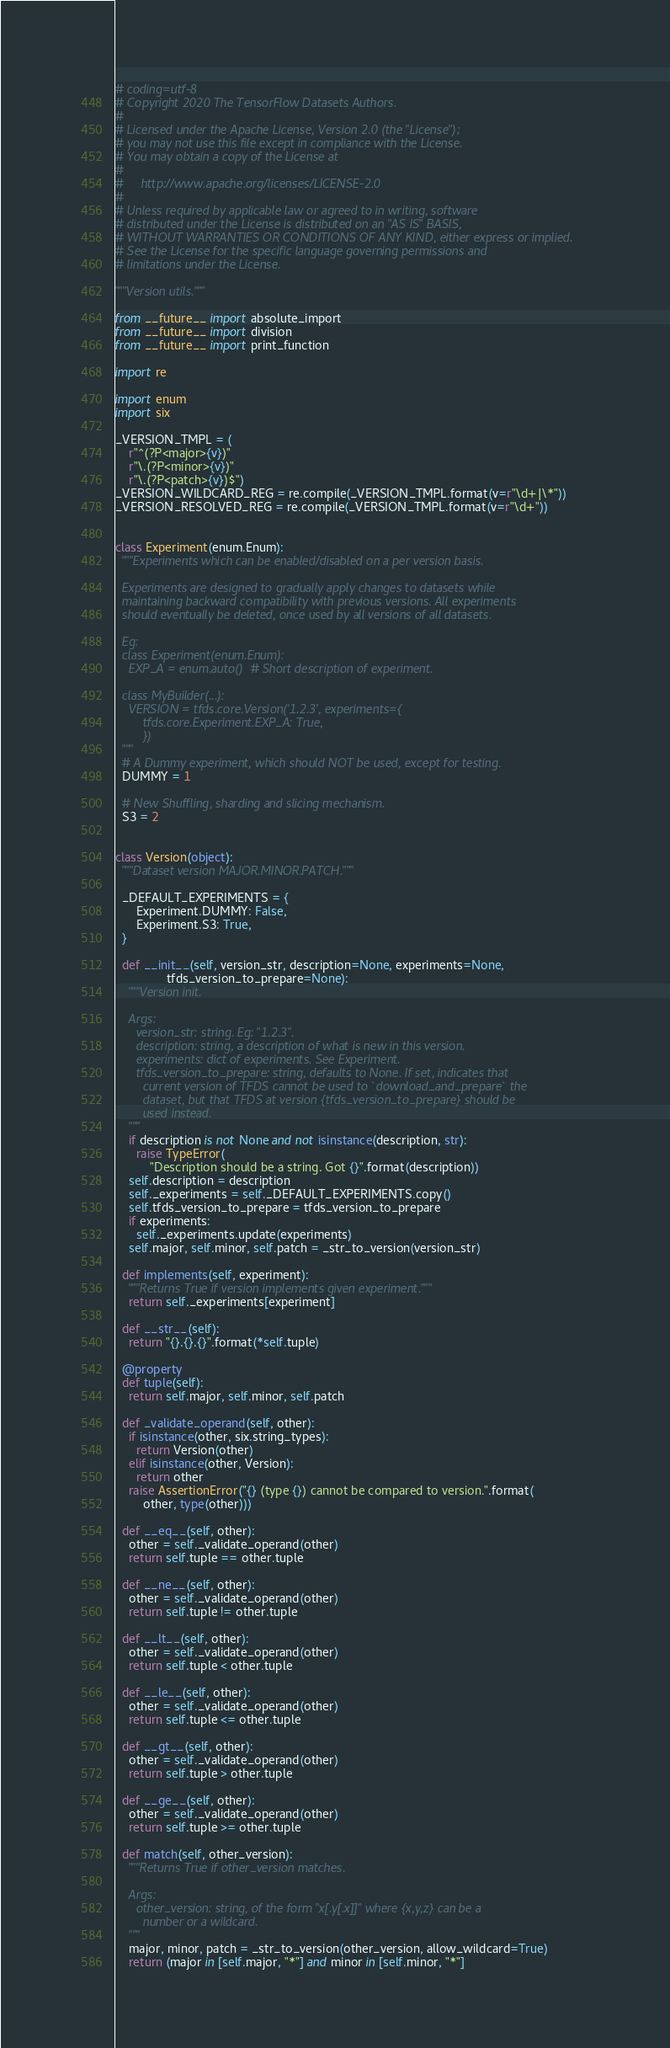Convert code to text. <code><loc_0><loc_0><loc_500><loc_500><_Python_># coding=utf-8
# Copyright 2020 The TensorFlow Datasets Authors.
#
# Licensed under the Apache License, Version 2.0 (the "License");
# you may not use this file except in compliance with the License.
# You may obtain a copy of the License at
#
#     http://www.apache.org/licenses/LICENSE-2.0
#
# Unless required by applicable law or agreed to in writing, software
# distributed under the License is distributed on an "AS IS" BASIS,
# WITHOUT WARRANTIES OR CONDITIONS OF ANY KIND, either express or implied.
# See the License for the specific language governing permissions and
# limitations under the License.

"""Version utils."""

from __future__ import absolute_import
from __future__ import division
from __future__ import print_function

import re

import enum
import six

_VERSION_TMPL = (
    r"^(?P<major>{v})"
    r"\.(?P<minor>{v})"
    r"\.(?P<patch>{v})$")
_VERSION_WILDCARD_REG = re.compile(_VERSION_TMPL.format(v=r"\d+|\*"))
_VERSION_RESOLVED_REG = re.compile(_VERSION_TMPL.format(v=r"\d+"))


class Experiment(enum.Enum):
  """Experiments which can be enabled/disabled on a per version basis.

  Experiments are designed to gradually apply changes to datasets while
  maintaining backward compatibility with previous versions. All experiments
  should eventually be deleted, once used by all versions of all datasets.

  Eg:
  class Experiment(enum.Enum):
    EXP_A = enum.auto()  # Short description of experiment.

  class MyBuilder(...):
    VERSION = tfds.core.Version('1.2.3', experiments={
        tfds.core.Experiment.EXP_A: True,
        })
  """
  # A Dummy experiment, which should NOT be used, except for testing.
  DUMMY = 1

  # New Shuffling, sharding and slicing mechanism.
  S3 = 2


class Version(object):
  """Dataset version MAJOR.MINOR.PATCH."""

  _DEFAULT_EXPERIMENTS = {
      Experiment.DUMMY: False,
      Experiment.S3: True,
  }

  def __init__(self, version_str, description=None, experiments=None,
               tfds_version_to_prepare=None):
    """Version init.

    Args:
      version_str: string. Eg: "1.2.3".
      description: string, a description of what is new in this version.
      experiments: dict of experiments. See Experiment.
      tfds_version_to_prepare: string, defaults to None. If set, indicates that
        current version of TFDS cannot be used to `download_and_prepare` the
        dataset, but that TFDS at version {tfds_version_to_prepare} should be
        used instead.
    """
    if description is not None and not isinstance(description, str):
      raise TypeError(
          "Description should be a string. Got {}".format(description))
    self.description = description
    self._experiments = self._DEFAULT_EXPERIMENTS.copy()
    self.tfds_version_to_prepare = tfds_version_to_prepare
    if experiments:
      self._experiments.update(experiments)
    self.major, self.minor, self.patch = _str_to_version(version_str)

  def implements(self, experiment):
    """Returns True if version implements given experiment."""
    return self._experiments[experiment]

  def __str__(self):
    return "{}.{}.{}".format(*self.tuple)

  @property
  def tuple(self):
    return self.major, self.minor, self.patch

  def _validate_operand(self, other):
    if isinstance(other, six.string_types):
      return Version(other)
    elif isinstance(other, Version):
      return other
    raise AssertionError("{} (type {}) cannot be compared to version.".format(
        other, type(other)))

  def __eq__(self, other):
    other = self._validate_operand(other)
    return self.tuple == other.tuple

  def __ne__(self, other):
    other = self._validate_operand(other)
    return self.tuple != other.tuple

  def __lt__(self, other):
    other = self._validate_operand(other)
    return self.tuple < other.tuple

  def __le__(self, other):
    other = self._validate_operand(other)
    return self.tuple <= other.tuple

  def __gt__(self, other):
    other = self._validate_operand(other)
    return self.tuple > other.tuple

  def __ge__(self, other):
    other = self._validate_operand(other)
    return self.tuple >= other.tuple

  def match(self, other_version):
    """Returns True if other_version matches.

    Args:
      other_version: string, of the form "x[.y[.x]]" where {x,y,z} can be a
        number or a wildcard.
    """
    major, minor, patch = _str_to_version(other_version, allow_wildcard=True)
    return (major in [self.major, "*"] and minor in [self.minor, "*"]</code> 